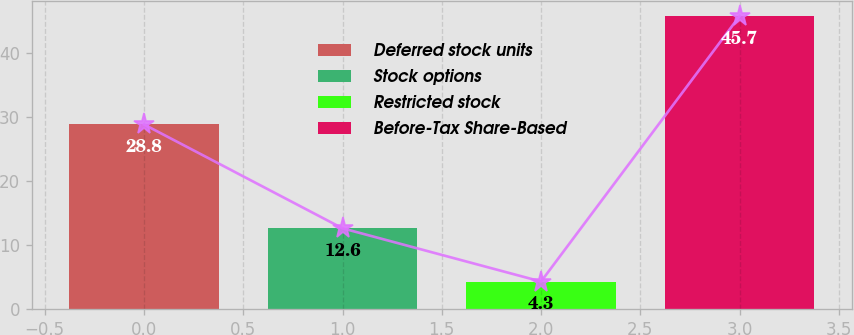<chart> <loc_0><loc_0><loc_500><loc_500><bar_chart><fcel>Deferred stock units<fcel>Stock options<fcel>Restricted stock<fcel>Before-Tax Share-Based<nl><fcel>28.8<fcel>12.6<fcel>4.3<fcel>45.7<nl></chart> 